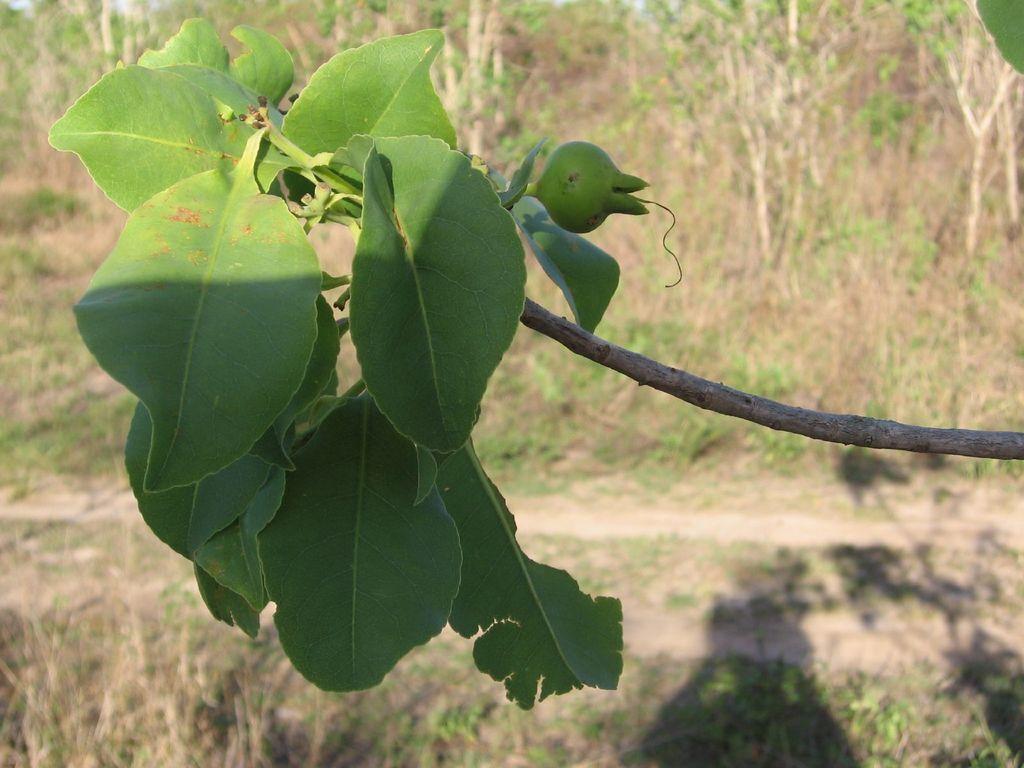How would you summarize this image in a sentence or two? There are leaves, fruit and a stem in the middle of this image, and there are trees in the background. 